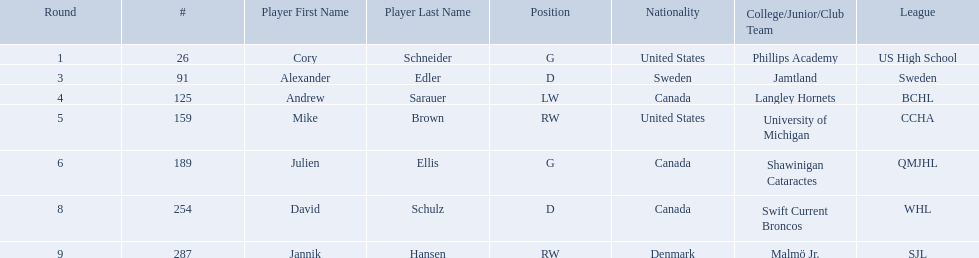What are the names of the colleges and jr leagues the players attended? Phillips Academy (US High School), Jamtland (Sweden), Langley Hornets (BCHL), University of Michigan (CCHA), Shawinigan Cataractes (QMJHL), Swift Current Broncos (WHL), Malmö Jr. (SJL). Which player played for the langley hornets? Andrew Sarauer (LW). Which players have canadian nationality? Andrew Sarauer (LW), Julien Ellis (G), David Schulz (D). Of those, which attended langley hornets? Andrew Sarauer (LW). 